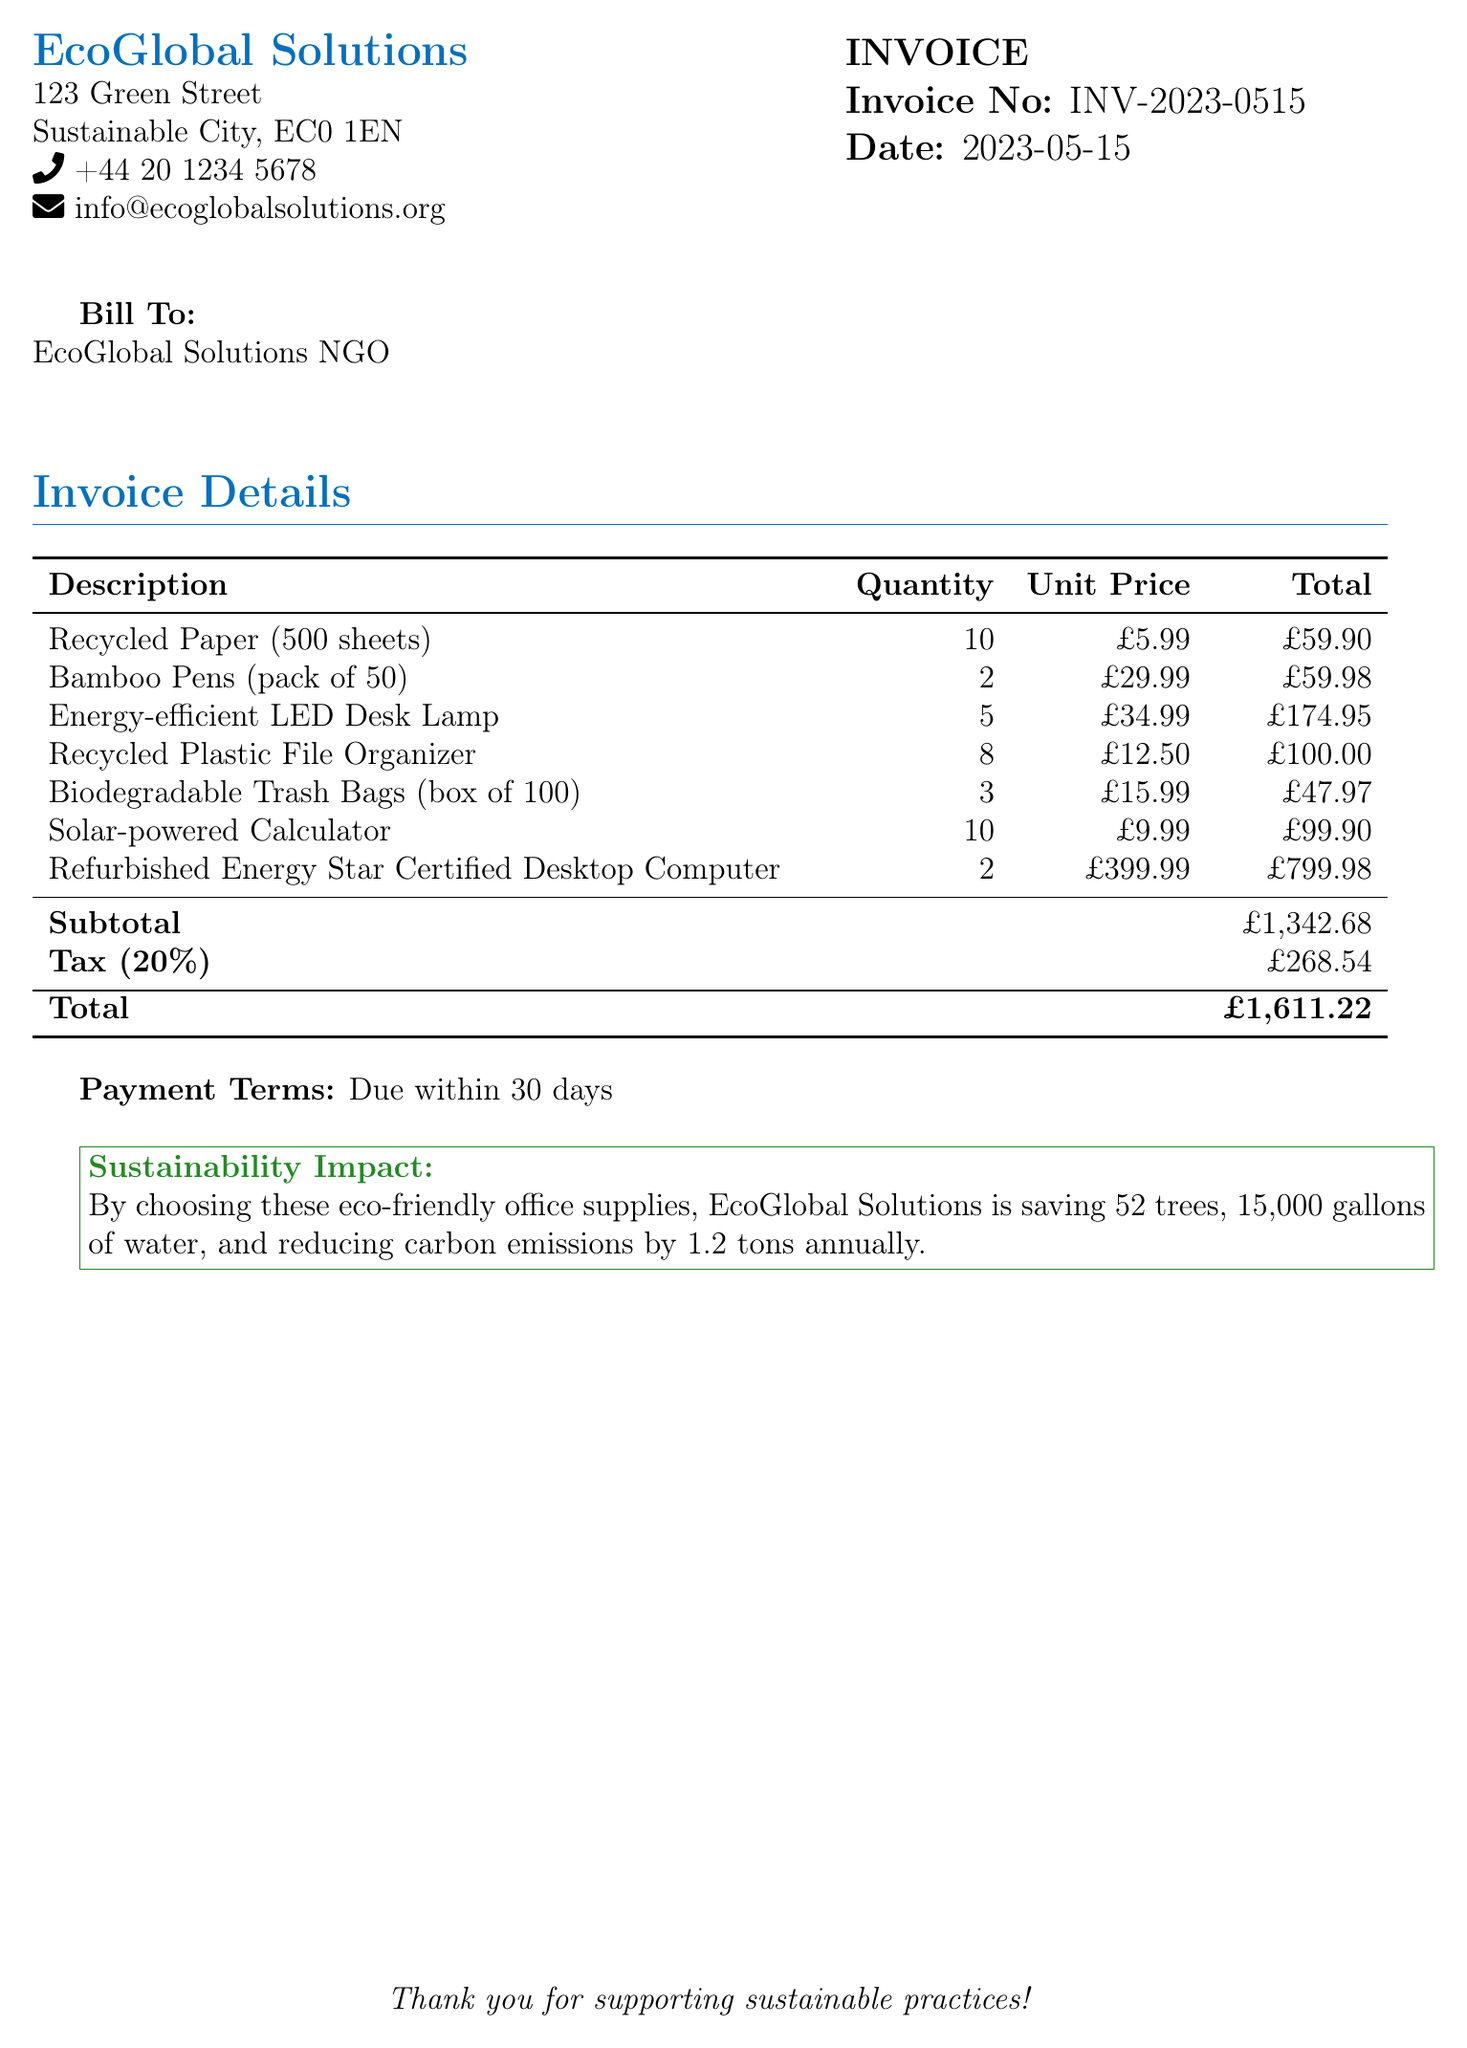what is the invoice number? The invoice number is listed on the document as a unique identifier for this transaction.
Answer: INV-2023-0515 what is the date of the invoice? The date indicates when the invoice was issued, which is crucial for payment tracking.
Answer: 2023-05-15 how many energy-efficient LED desk lamps were purchased? This quantity is found in the details of the purchased items listed in the invoice.
Answer: 5 what is the subtotal amount before tax? The subtotal is the total of all items before tax is applied, listed in the calculations.
Answer: £1,342.68 what percentage is the tax applied? The tax rate is specified to compute how much tax is added to the subtotal.
Answer: 20% what is the total amount due? The total includes both the subtotal and the tax amount, summarizing the overall amount required.
Answer: £1,611.22 how many trees does the NGO save by purchasing these supplies? This environmental impact detail highlights the sustainability benefits of the purchases made.
Answer: 52 what type of business is EcoGlobal Solutions? The name and context suggest the nature of the organization's focus, especially through its initiatives.
Answer: NGO what does the payment term specify? Payment terms indicate when the company expects to receive payment, which is important for financial planning.
Answer: Due within 30 days 